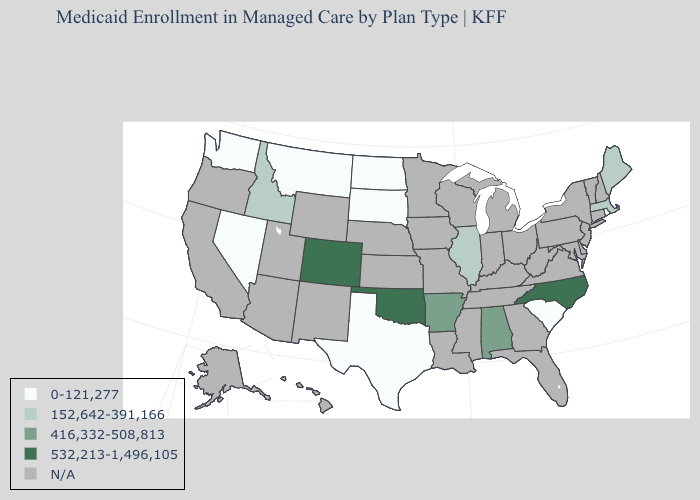Is the legend a continuous bar?
Answer briefly. No. Name the states that have a value in the range N/A?
Write a very short answer. Alaska, Arizona, California, Connecticut, Delaware, Florida, Georgia, Hawaii, Indiana, Iowa, Kansas, Kentucky, Louisiana, Maryland, Michigan, Minnesota, Mississippi, Missouri, Nebraska, New Hampshire, New Jersey, New Mexico, New York, Ohio, Oregon, Pennsylvania, Tennessee, Utah, Vermont, Virginia, West Virginia, Wisconsin, Wyoming. What is the value of Kansas?
Write a very short answer. N/A. Does the map have missing data?
Give a very brief answer. Yes. What is the value of Oregon?
Keep it brief. N/A. Does Maine have the lowest value in the USA?
Write a very short answer. No. Name the states that have a value in the range N/A?
Concise answer only. Alaska, Arizona, California, Connecticut, Delaware, Florida, Georgia, Hawaii, Indiana, Iowa, Kansas, Kentucky, Louisiana, Maryland, Michigan, Minnesota, Mississippi, Missouri, Nebraska, New Hampshire, New Jersey, New Mexico, New York, Ohio, Oregon, Pennsylvania, Tennessee, Utah, Vermont, Virginia, West Virginia, Wisconsin, Wyoming. How many symbols are there in the legend?
Keep it brief. 5. Name the states that have a value in the range 416,332-508,813?
Quick response, please. Alabama, Arkansas. Name the states that have a value in the range 532,213-1,496,105?
Answer briefly. Colorado, North Carolina, Oklahoma. Name the states that have a value in the range 0-121,277?
Keep it brief. Montana, Nevada, North Dakota, Rhode Island, South Carolina, South Dakota, Texas, Washington. Which states have the lowest value in the South?
Keep it brief. South Carolina, Texas. What is the value of Oklahoma?
Keep it brief. 532,213-1,496,105. What is the value of Georgia?
Answer briefly. N/A. 